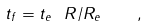Convert formula to latex. <formula><loc_0><loc_0><loc_500><loc_500>t _ { f } = t _ { e } \ R / R _ { e } \quad ,</formula> 